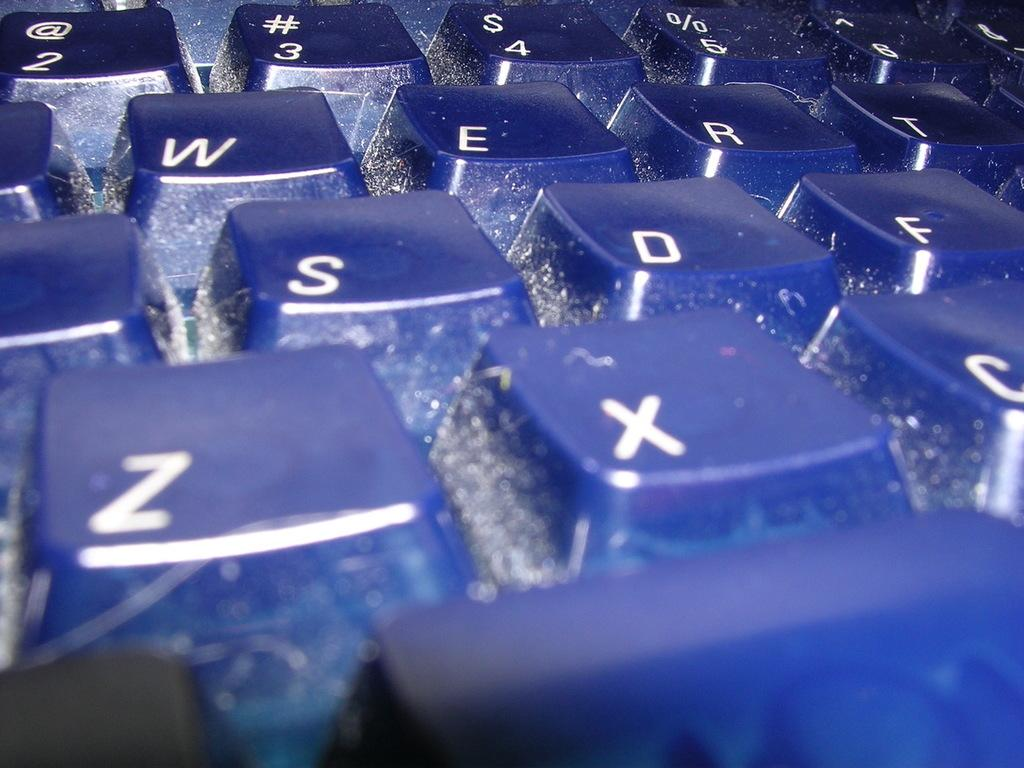<image>
Write a terse but informative summary of the picture. a dirty keyboard showing specifically 'z' and 'x' on it 